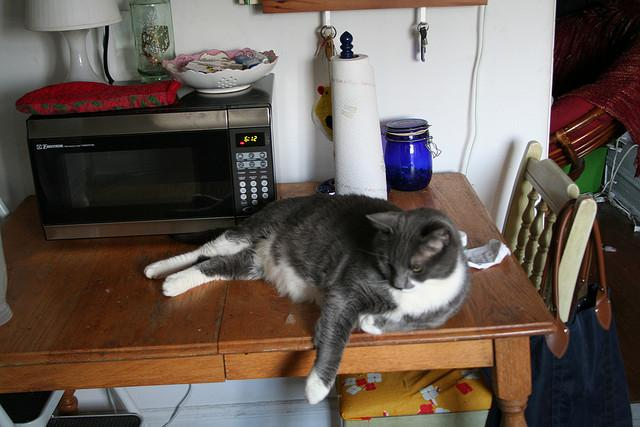What is illuminating the cat and the table? Please explain your reasoning. sunlight. The light is not coming from one place, rather it is light in general. 